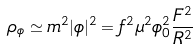<formula> <loc_0><loc_0><loc_500><loc_500>\rho _ { \phi } \simeq m ^ { 2 } | \phi | ^ { 2 } = f ^ { 2 } \mu ^ { 2 } \phi _ { 0 } ^ { 2 } \frac { F ^ { 2 } } { R ^ { 2 } }</formula> 